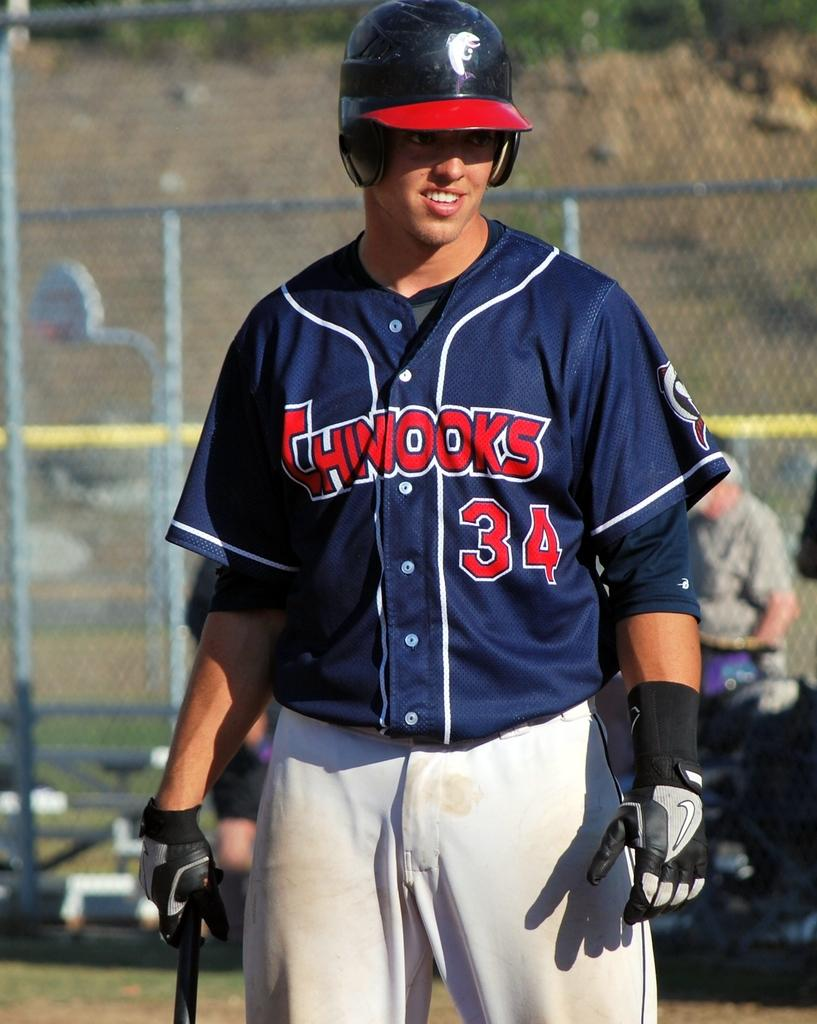<image>
Offer a succinct explanation of the picture presented. A man wearing a Chinooks baseball uniform holds a bat. 